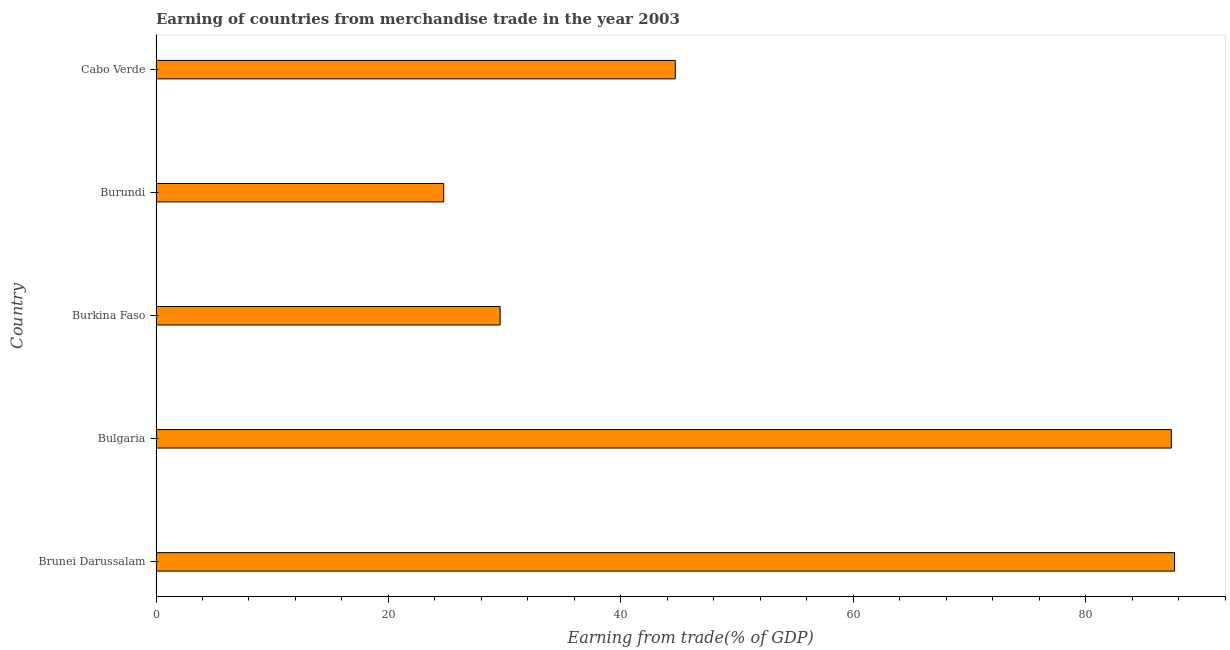What is the title of the graph?
Make the answer very short. Earning of countries from merchandise trade in the year 2003. What is the label or title of the X-axis?
Give a very brief answer. Earning from trade(% of GDP). What is the earning from merchandise trade in Bulgaria?
Provide a short and direct response. 87.38. Across all countries, what is the maximum earning from merchandise trade?
Your response must be concise. 87.66. Across all countries, what is the minimum earning from merchandise trade?
Offer a very short reply. 24.76. In which country was the earning from merchandise trade maximum?
Provide a short and direct response. Brunei Darussalam. In which country was the earning from merchandise trade minimum?
Offer a terse response. Burundi. What is the sum of the earning from merchandise trade?
Your response must be concise. 274.1. What is the difference between the earning from merchandise trade in Bulgaria and Cabo Verde?
Offer a terse response. 42.69. What is the average earning from merchandise trade per country?
Offer a very short reply. 54.82. What is the median earning from merchandise trade?
Your response must be concise. 44.69. What is the ratio of the earning from merchandise trade in Bulgaria to that in Cabo Verde?
Ensure brevity in your answer.  1.96. Is the earning from merchandise trade in Brunei Darussalam less than that in Cabo Verde?
Your answer should be compact. No. Is the difference between the earning from merchandise trade in Burundi and Cabo Verde greater than the difference between any two countries?
Offer a very short reply. No. What is the difference between the highest and the second highest earning from merchandise trade?
Your answer should be very brief. 0.28. Is the sum of the earning from merchandise trade in Brunei Darussalam and Burundi greater than the maximum earning from merchandise trade across all countries?
Offer a very short reply. Yes. What is the difference between the highest and the lowest earning from merchandise trade?
Your answer should be very brief. 62.9. In how many countries, is the earning from merchandise trade greater than the average earning from merchandise trade taken over all countries?
Your answer should be compact. 2. How many bars are there?
Keep it short and to the point. 5. Are all the bars in the graph horizontal?
Provide a succinct answer. Yes. Are the values on the major ticks of X-axis written in scientific E-notation?
Your answer should be very brief. No. What is the Earning from trade(% of GDP) in Brunei Darussalam?
Your response must be concise. 87.66. What is the Earning from trade(% of GDP) in Bulgaria?
Ensure brevity in your answer.  87.38. What is the Earning from trade(% of GDP) in Burkina Faso?
Your answer should be very brief. 29.62. What is the Earning from trade(% of GDP) in Burundi?
Offer a very short reply. 24.76. What is the Earning from trade(% of GDP) of Cabo Verde?
Give a very brief answer. 44.69. What is the difference between the Earning from trade(% of GDP) in Brunei Darussalam and Bulgaria?
Your answer should be very brief. 0.28. What is the difference between the Earning from trade(% of GDP) in Brunei Darussalam and Burkina Faso?
Keep it short and to the point. 58.04. What is the difference between the Earning from trade(% of GDP) in Brunei Darussalam and Burundi?
Your answer should be very brief. 62.9. What is the difference between the Earning from trade(% of GDP) in Brunei Darussalam and Cabo Verde?
Offer a very short reply. 42.97. What is the difference between the Earning from trade(% of GDP) in Bulgaria and Burkina Faso?
Provide a short and direct response. 57.76. What is the difference between the Earning from trade(% of GDP) in Bulgaria and Burundi?
Your response must be concise. 62.62. What is the difference between the Earning from trade(% of GDP) in Bulgaria and Cabo Verde?
Offer a very short reply. 42.69. What is the difference between the Earning from trade(% of GDP) in Burkina Faso and Burundi?
Make the answer very short. 4.86. What is the difference between the Earning from trade(% of GDP) in Burkina Faso and Cabo Verde?
Make the answer very short. -15.07. What is the difference between the Earning from trade(% of GDP) in Burundi and Cabo Verde?
Ensure brevity in your answer.  -19.93. What is the ratio of the Earning from trade(% of GDP) in Brunei Darussalam to that in Bulgaria?
Ensure brevity in your answer.  1. What is the ratio of the Earning from trade(% of GDP) in Brunei Darussalam to that in Burkina Faso?
Your answer should be compact. 2.96. What is the ratio of the Earning from trade(% of GDP) in Brunei Darussalam to that in Burundi?
Provide a short and direct response. 3.54. What is the ratio of the Earning from trade(% of GDP) in Brunei Darussalam to that in Cabo Verde?
Offer a terse response. 1.96. What is the ratio of the Earning from trade(% of GDP) in Bulgaria to that in Burkina Faso?
Offer a very short reply. 2.95. What is the ratio of the Earning from trade(% of GDP) in Bulgaria to that in Burundi?
Provide a short and direct response. 3.53. What is the ratio of the Earning from trade(% of GDP) in Bulgaria to that in Cabo Verde?
Provide a succinct answer. 1.96. What is the ratio of the Earning from trade(% of GDP) in Burkina Faso to that in Burundi?
Your response must be concise. 1.2. What is the ratio of the Earning from trade(% of GDP) in Burkina Faso to that in Cabo Verde?
Your response must be concise. 0.66. What is the ratio of the Earning from trade(% of GDP) in Burundi to that in Cabo Verde?
Keep it short and to the point. 0.55. 